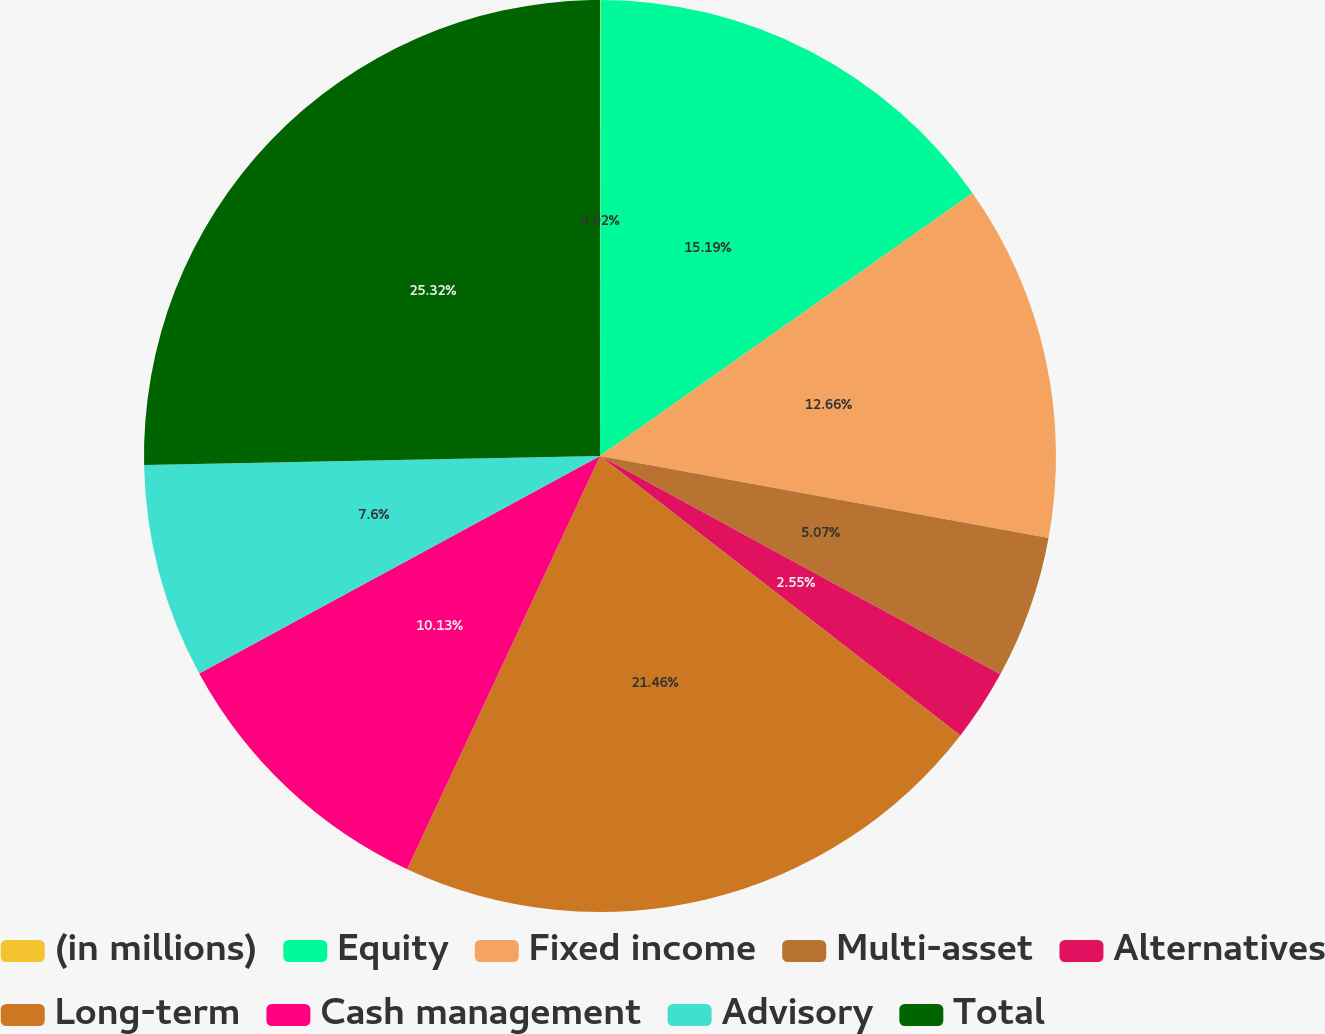Convert chart. <chart><loc_0><loc_0><loc_500><loc_500><pie_chart><fcel>(in millions)<fcel>Equity<fcel>Fixed income<fcel>Multi-asset<fcel>Alternatives<fcel>Long-term<fcel>Cash management<fcel>Advisory<fcel>Total<nl><fcel>0.02%<fcel>15.19%<fcel>12.66%<fcel>5.07%<fcel>2.55%<fcel>21.45%<fcel>10.13%<fcel>7.6%<fcel>25.31%<nl></chart> 